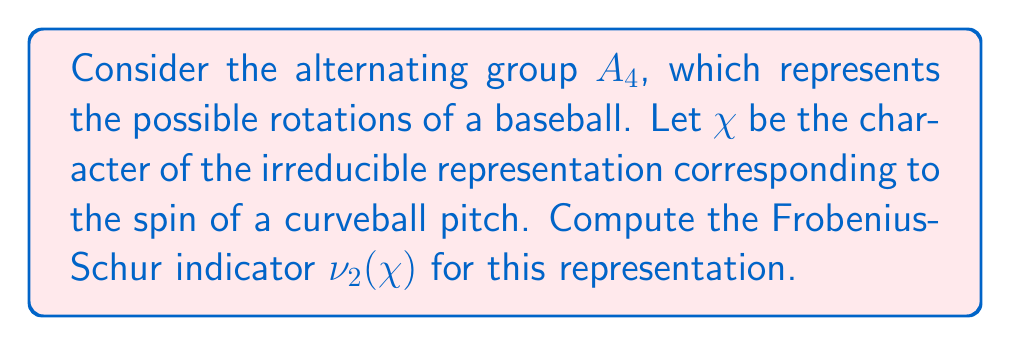Could you help me with this problem? To compute the Frobenius-Schur indicator $\nu_2(\chi)$ for the given representation, we'll follow these steps:

1) The Frobenius-Schur indicator is defined as:

   $$\nu_2(\chi) = \frac{1}{|G|} \sum_{g \in G} \chi(g^2)$$

   where $G$ is the group (in this case, $A_4$) and $\chi$ is the character of the representation.

2) The alternating group $A_4$ has 12 elements, so $|A_4| = 12$.

3) The conjugacy classes of $A_4$ are:
   - $C_1 = \{e\}$ (identity)
   - $C_2 = \{(12)(34), (13)(24), (14)(23)\}$ (products of two 2-cycles)
   - $C_3 = \{(123), (132), (124), (142), (134), (143), (234), (243)\}$ (3-cycles)

4) For a curveball pitch representation, we can assume the character values are:
   $\chi(e) = 3$, $\chi((12)(34)) = -1$, $\chi((123)) = 0$

5) Now, let's compute $\chi(g^2)$ for each conjugacy class:
   - For $C_1$: $e^2 = e$, so $\chi(e^2) = 3$
   - For $C_2$: $((12)(34))^2 = e$, so $\chi(((12)(34))^2) = 3$
   - For $C_3$: $((123))^2 = (132)$, so $\chi(((123))^2) = 0$

6) Applying the formula:

   $$\nu_2(\chi) = \frac{1}{12} [1 \cdot 3 + 3 \cdot 3 + 8 \cdot 0] = \frac{1}{12} [3 + 9 + 0] = 1$$

Therefore, the Frobenius-Schur indicator for this representation is 1.
Answer: $\nu_2(\chi) = 1$ 